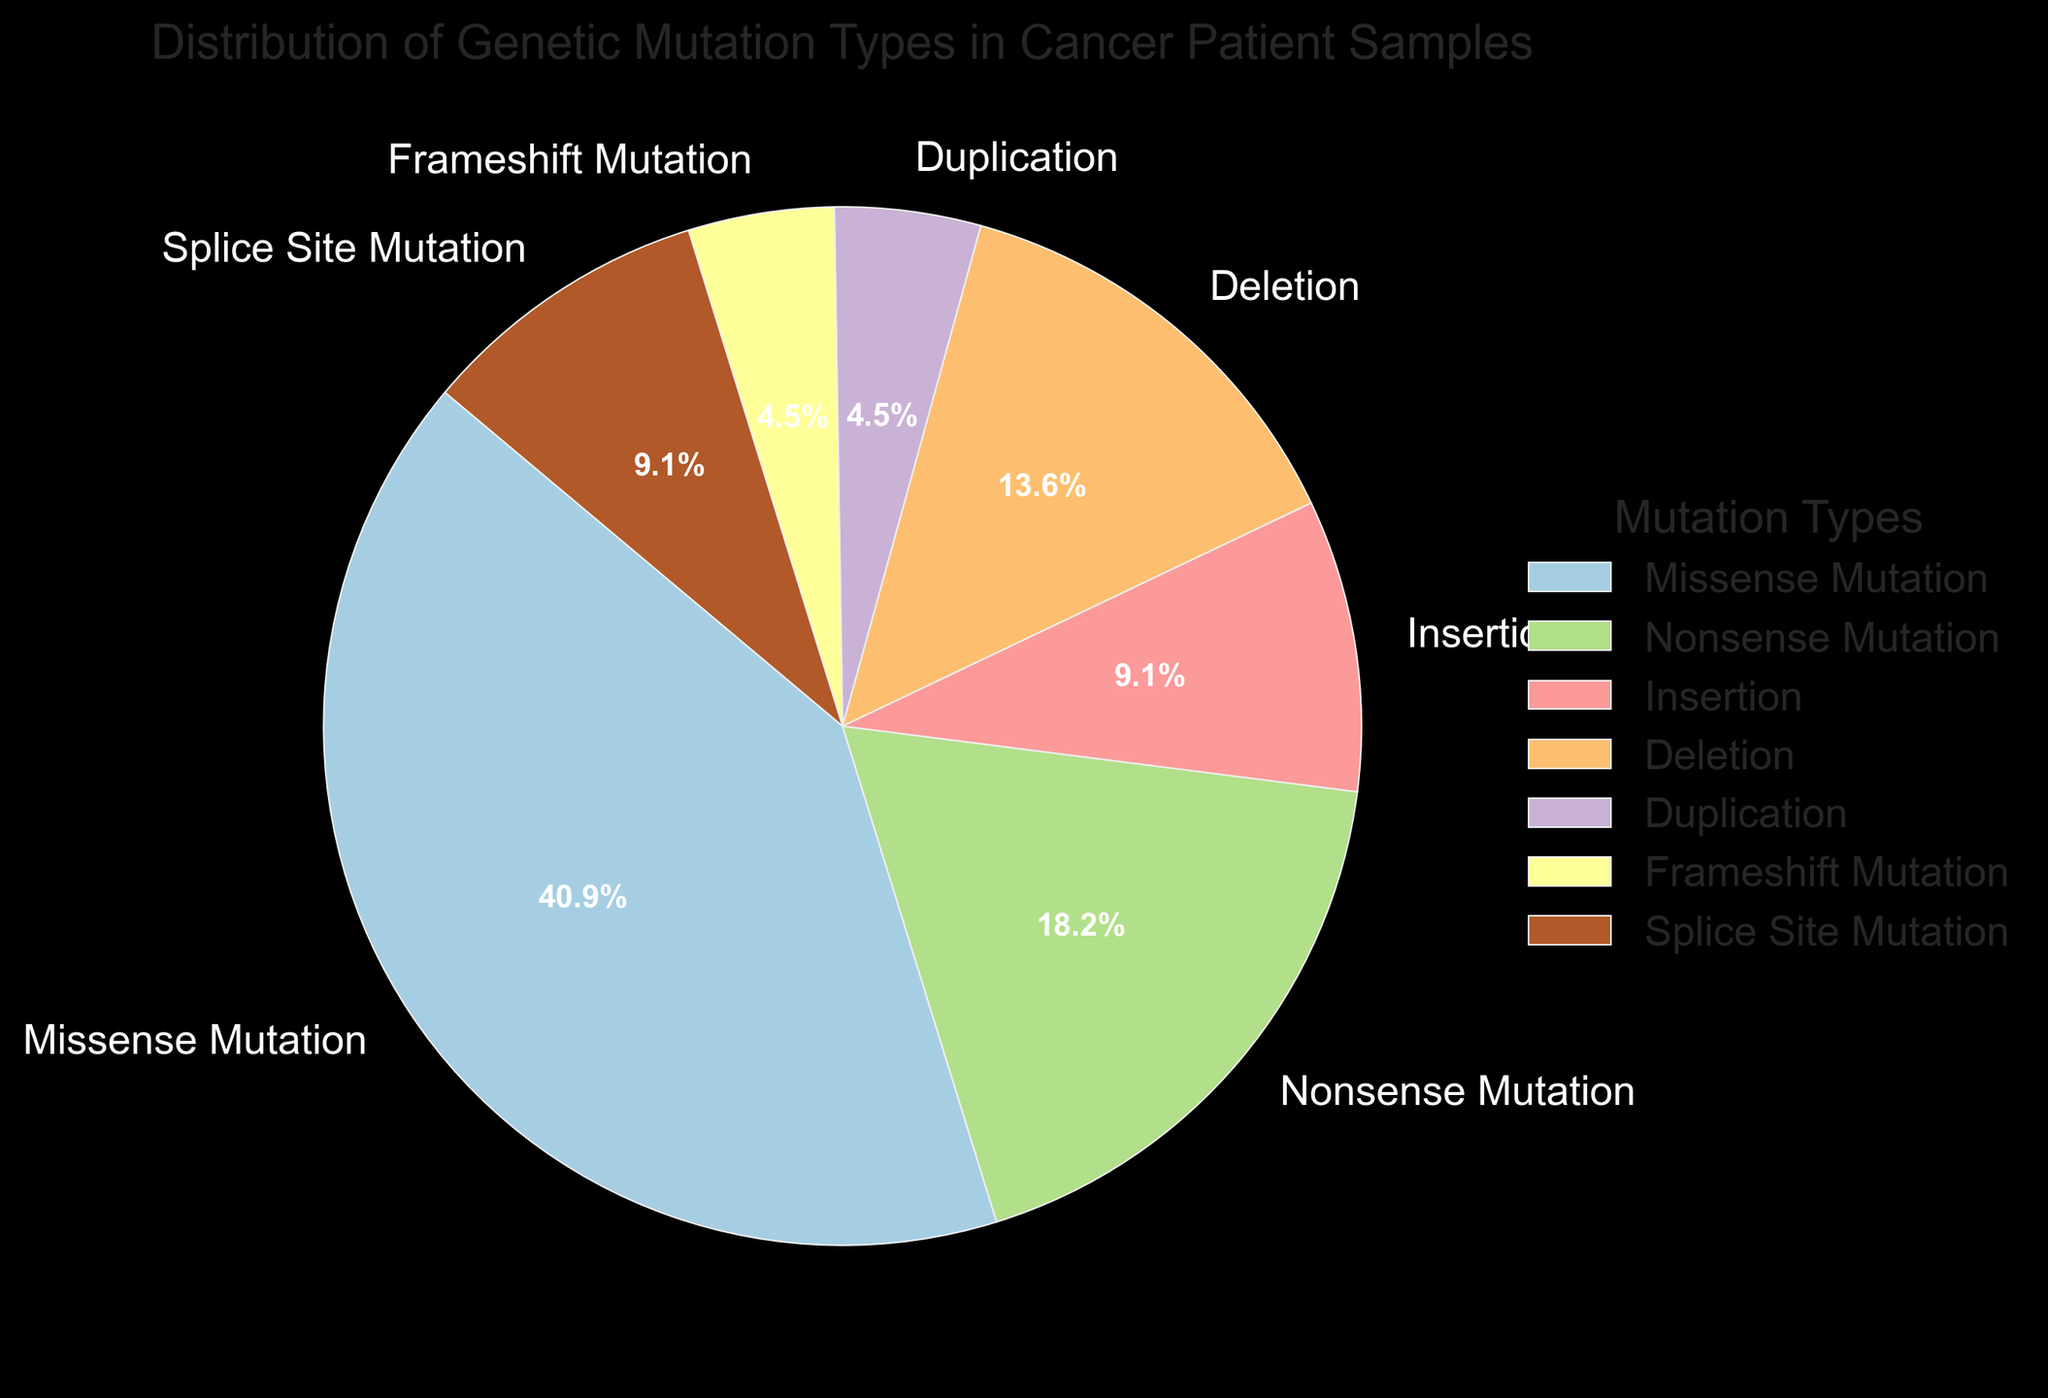What is the most common type of genetic mutation in cancer patient samples? The most common type of genetic mutation can be identified by looking at the label with the largest percentage in the pie chart. This label is Missense Mutation.
Answer: Missense Mutation Which mutation types have the same percentage distribution? To find mutation types with the same percentage distribution, examine the percentage values in the pie chart for equal numbers. Insertion and Splice Site Mutation both have 10%. Frameshift Mutation and Duplication each have 5%.
Answer: Insertion and Splice Site Mutation; Frameshift Mutation and Duplication What is the combined percentage of Insertion and Deletion mutations? Sum the percentages of Insertion and Deletion from the pie chart. The percentage for Insertion is 10%, and for Deletion, it is 15%. Adding them together, 10% + 15% = 25%.
Answer: 25% How does the percentage of Nonsense Mutation compare to that of Deletion? Compare the percentage values from the pie chart. The percentage for Nonsense Mutation is 20%, and for Deletion, it is 15%. Comparing these, Nonsense Mutation's percentage is greater than Deletion's.
Answer: Nonsense Mutation > Deletion What percentage do the three least common mutation types constitute together? Identify the three mutation types with the smallest percentages: Duplication (5%), Frameshift Mutation (5%), and one more (there are only two mutation types sharing the smallest percentages). Adding them together, 5% + 5% = 10%.
Answer: 10% What is the percentage difference between Missense Mutation and Splice Site Mutation? Subtract the percentage for Splice Site Mutation from Missense Mutation using the values in the pie chart. Missense Mutation is 45%, and Splice Site Mutation is 10%. The difference is 45% - 10% = 35%.
Answer: 35% What mutation type is represented with a color slightly different from the next segment in the chart (i.e., adjacent segment color difference)? In the pie chart, the segment colors are visually distinct but adjacent segments will have colors that are closest to each other in the spectrum. Look for segment pairs with similar hues. The colors ensure clear distinction, identifying specific color differences might be subjective without the actual chart.
Answer: Subjective without visual If Missense Mutation and Nonsense Mutation are grouped together, what would be their combined percentage? Add the percentages of Missense Mutation and Nonsense Mutation. Missense Mutation is 45% and Nonsense Mutation is 20%, so their combined percentage is 45% + 20% = 65%.
Answer: 65% Which mutation type has a percentage that is half of the percentage of Deletion? Find the mutation type with a percentage half of Deletion's from the pie chart. Deletion is 15%, half of which is 7.5%. There is no mutation type with exactly 7.5%, thus no direct match.
Answer: None 